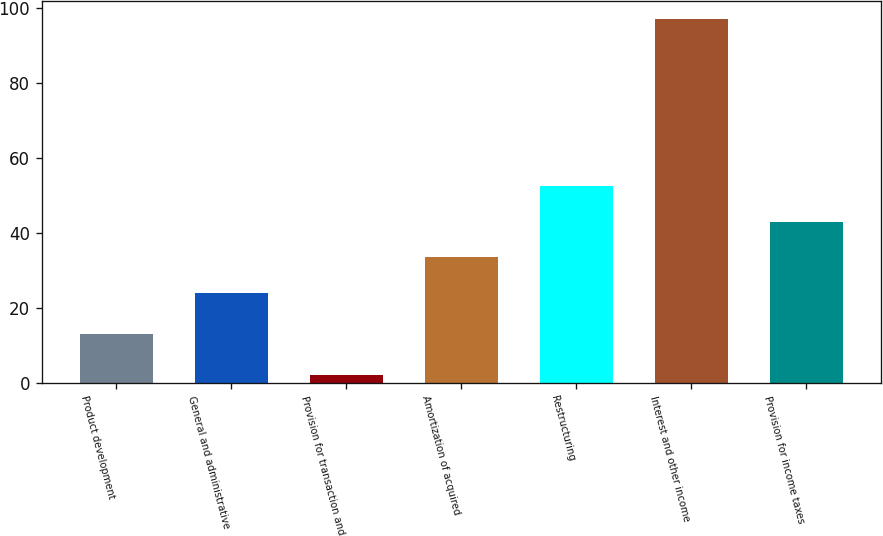<chart> <loc_0><loc_0><loc_500><loc_500><bar_chart><fcel>Product development<fcel>General and administrative<fcel>Provision for transaction and<fcel>Amortization of acquired<fcel>Restructuring<fcel>Interest and other income<fcel>Provision for income taxes<nl><fcel>13<fcel>24<fcel>2<fcel>33.5<fcel>52.5<fcel>97<fcel>43<nl></chart> 